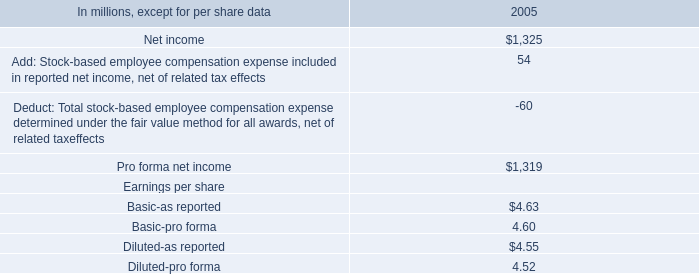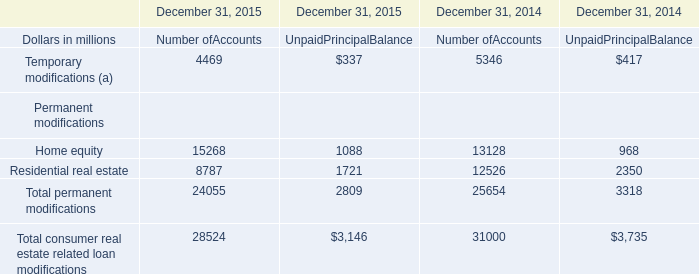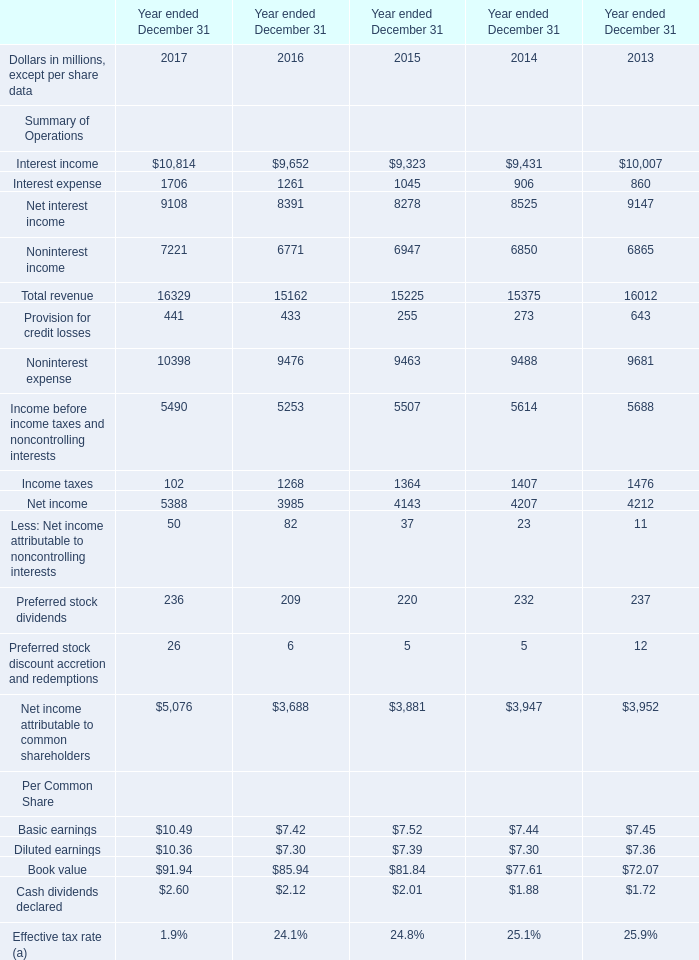What is the average amount of Noninterest expense of Year ended December 31 2017, and Home equity Permanent modifications of December 31, 2015 Number ofAccounts ? 
Computations: ((10398.0 + 15268.0) / 2)
Answer: 12833.0. 